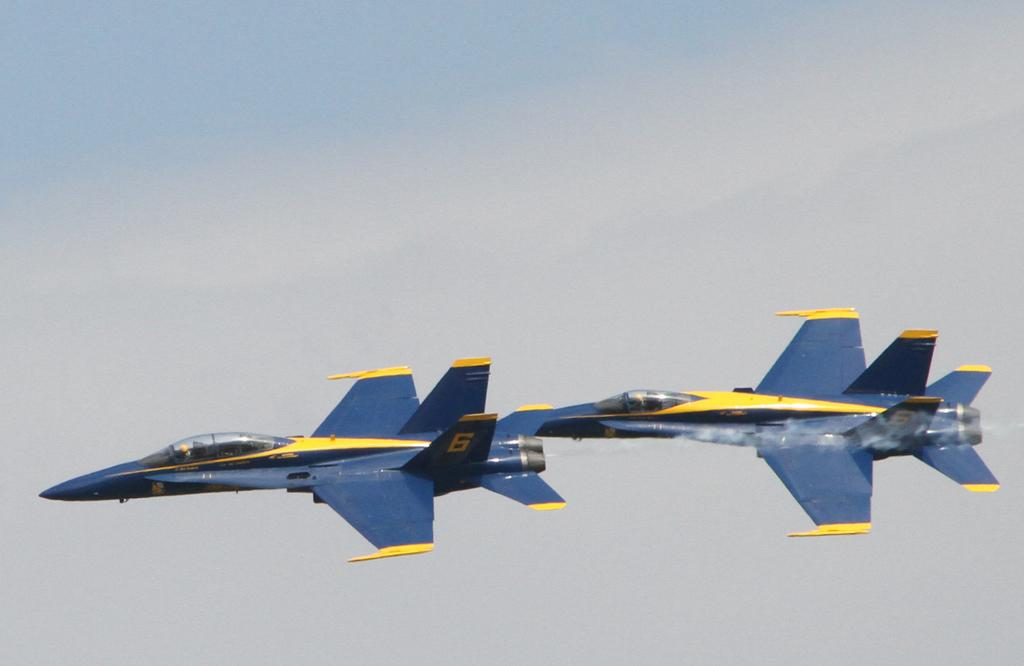Provide a one-sentence caption for the provided image. Two blue airplanes fly together, each with 6 on their tails. 